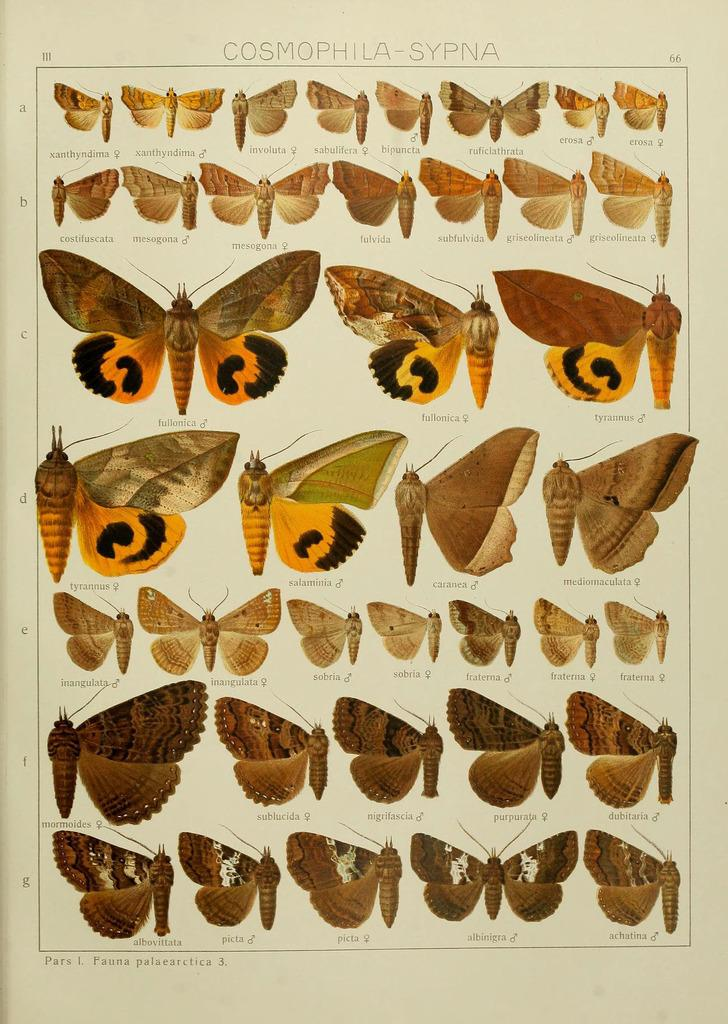What type of animals can be seen in the picture? There are butterflies in the picture. What additional information is associated with the butterflies? The butterflies have some information associated with them. Where can the alphabets be found in the picture? The alphabets are on the left side of the picture, arranged from top to bottom. What type of bone can be seen in the picture? There is no bone present in the picture; it features butterflies and alphabets. What desire is being expressed by the butterflies in the picture? Butterflies do not have desires, as they are insects and not sentient beings. 